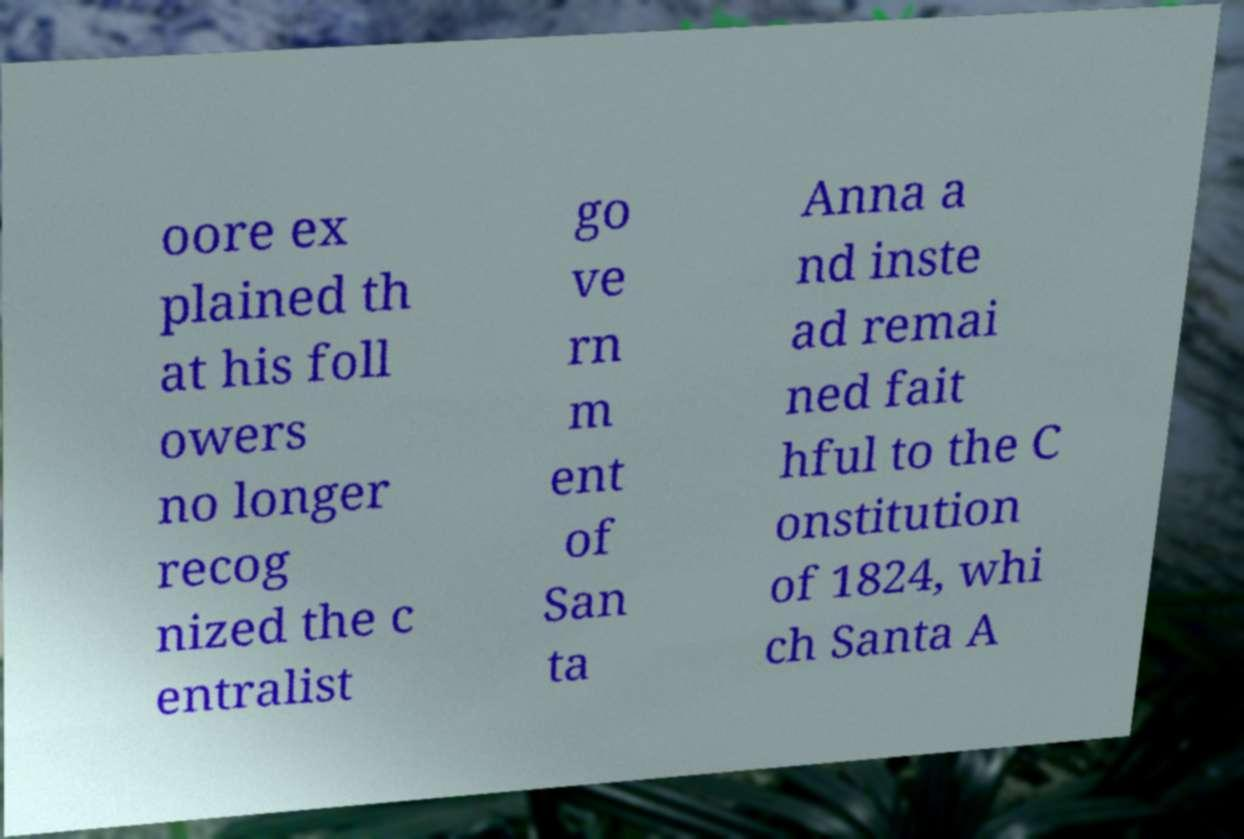There's text embedded in this image that I need extracted. Can you transcribe it verbatim? oore ex plained th at his foll owers no longer recog nized the c entralist go ve rn m ent of San ta Anna a nd inste ad remai ned fait hful to the C onstitution of 1824, whi ch Santa A 